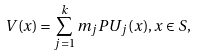<formula> <loc_0><loc_0><loc_500><loc_500>V ( x ) = \sum _ { j = 1 } ^ { k } m _ { j } P U _ { j } ( x ) , x \in S ,</formula> 